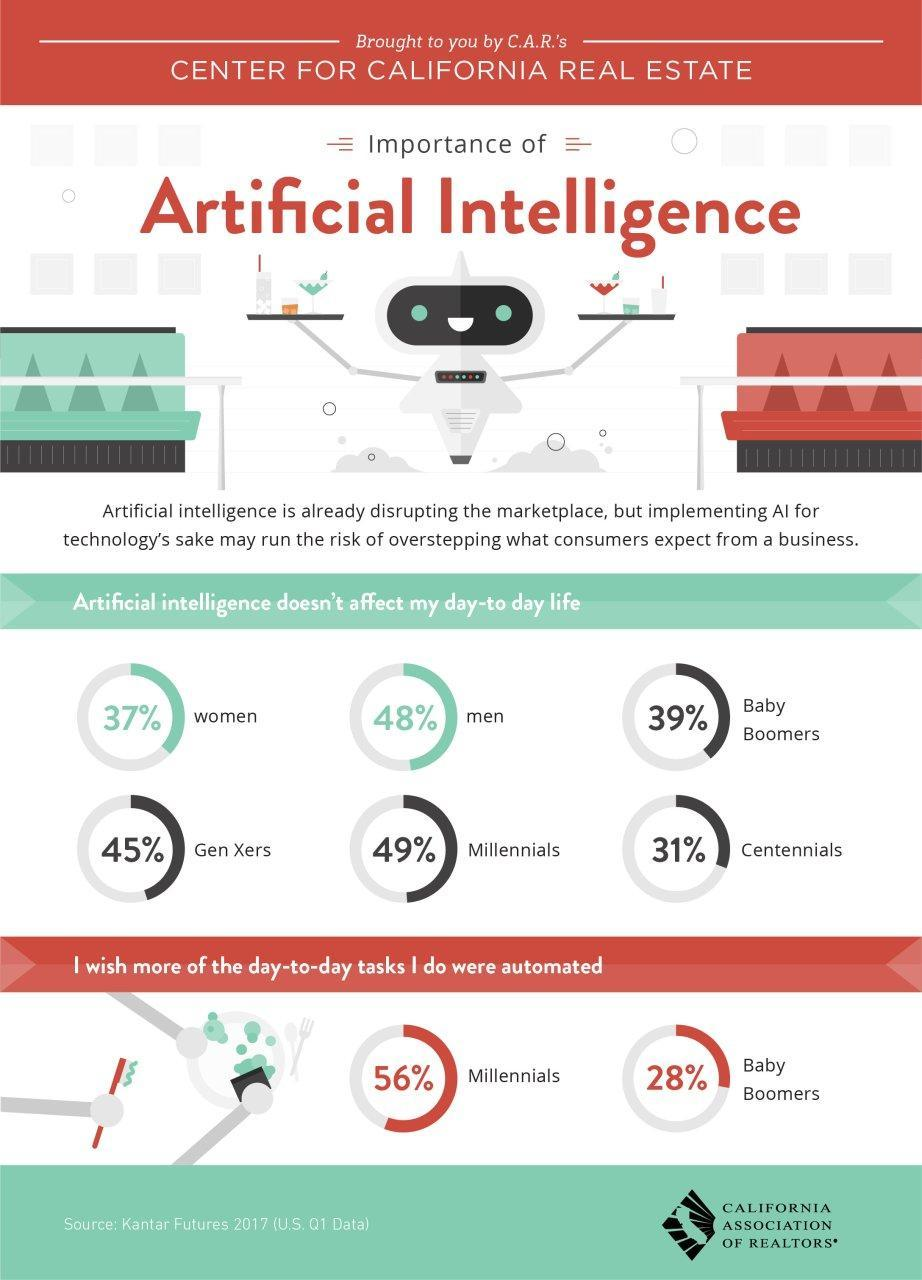What percent of millennials want more of their daily tasks to be automated?
Answer the question with a short phrase. 56% What percentage of women feel that their daily life is not affected by AI? 63 What percentage of millennials feel their daily life is affected by AI? 51 What percentage of the millennials do not want their daily tasks to be automated? 44 What percentage of baby boomers feel their daily life is not affected by AI? 61 What percentage of centennials feel that their daily life is not affected by AI? 69 What percentage of baby boomers do not want their daily tasks to be automated? 72 How many generations are compared here? 4 What percentage of the millennials feel that their daily life is not really affected by artificial intelligence? 49% What percent of Baby Boomers want more of their daily tasks to be automated? 28% 